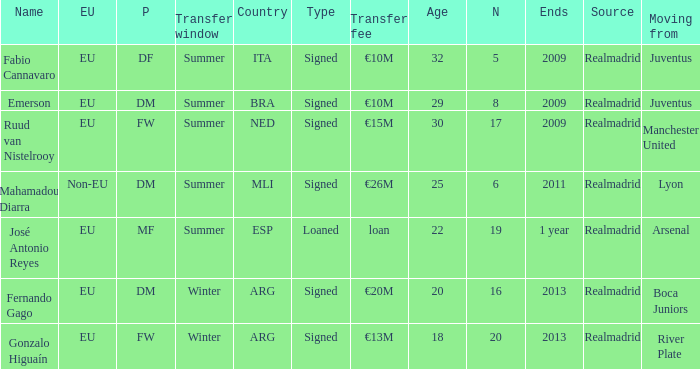What is the EU status of ESP? EU. 